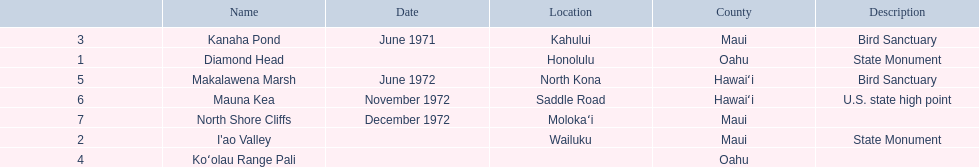What are all the landmark names? Diamond Head, I'ao Valley, Kanaha Pond, Koʻolau Range Pali, Makalawena Marsh, Mauna Kea, North Shore Cliffs. Which county is each landlord in? Oahu, Maui, Maui, Oahu, Hawaiʻi, Hawaiʻi, Maui. Along with mauna kea, which landmark is in hawai'i county? Makalawena Marsh. 